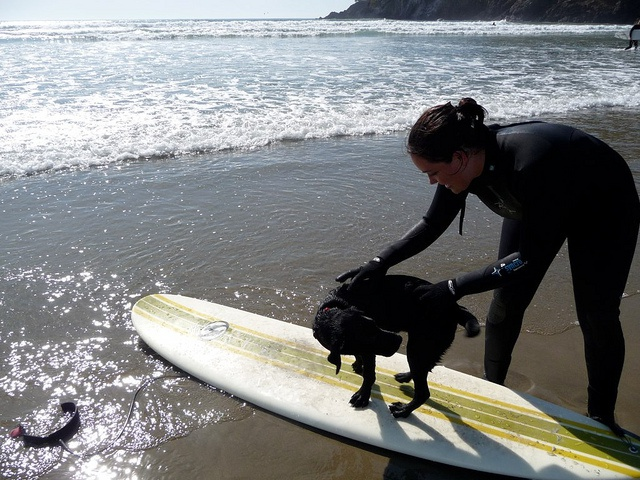Describe the objects in this image and their specific colors. I can see people in lightgray, black, and gray tones, surfboard in lightgray, ivory, gray, beige, and olive tones, and dog in lightgray, black, gray, ivory, and tan tones in this image. 